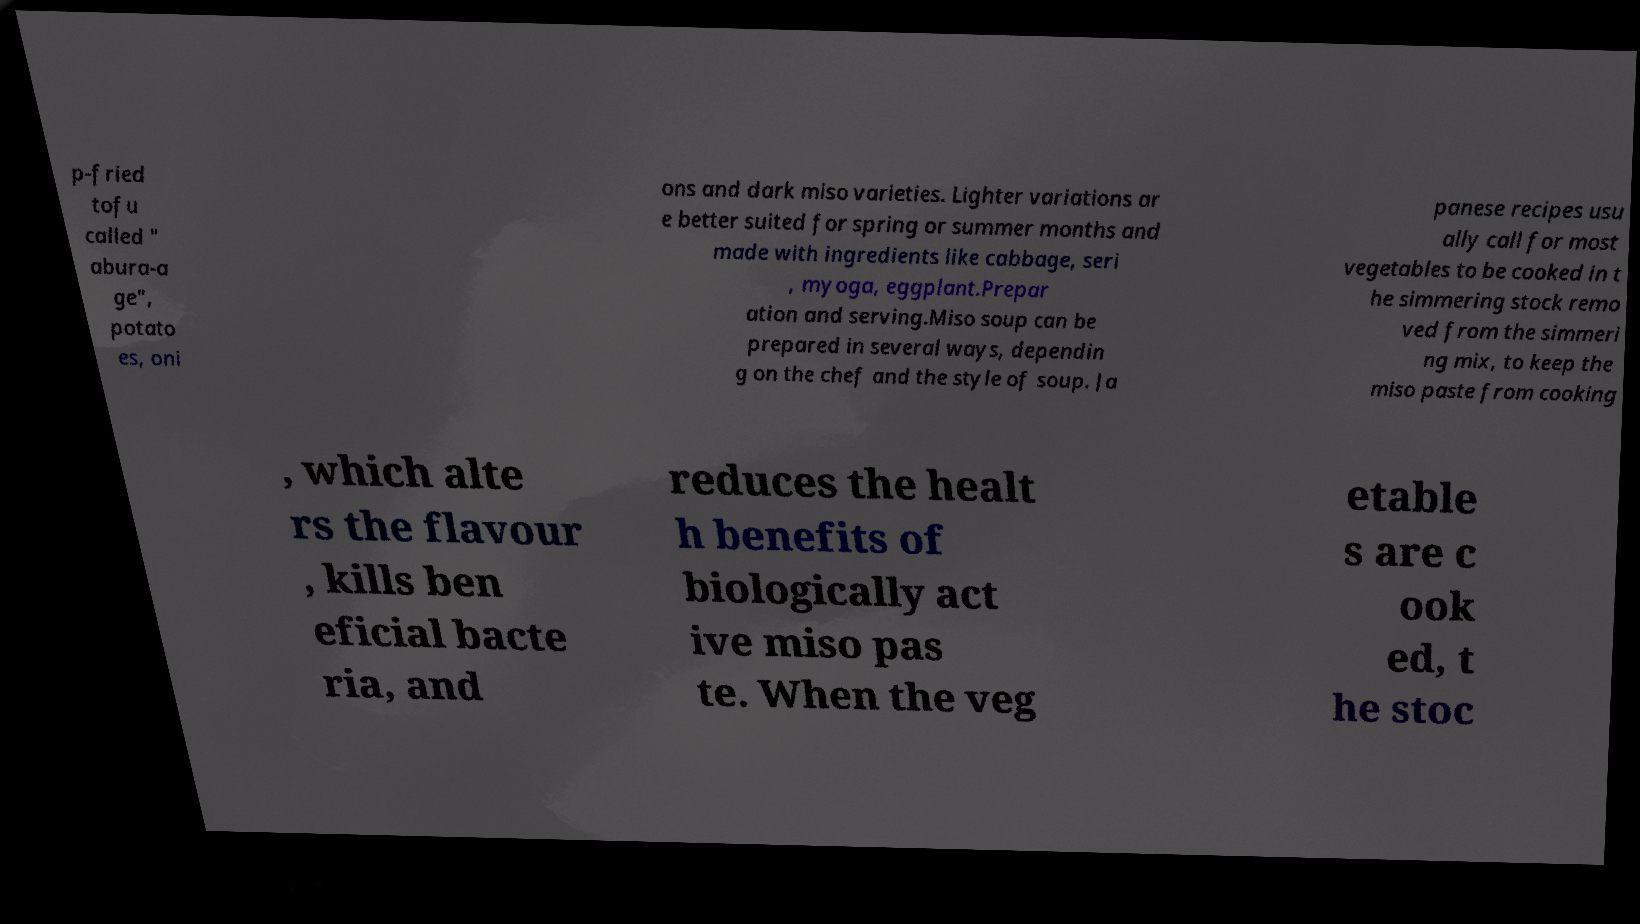Could you extract and type out the text from this image? p-fried tofu called " abura-a ge", potato es, oni ons and dark miso varieties. Lighter variations ar e better suited for spring or summer months and made with ingredients like cabbage, seri , myoga, eggplant.Prepar ation and serving.Miso soup can be prepared in several ways, dependin g on the chef and the style of soup. Ja panese recipes usu ally call for most vegetables to be cooked in t he simmering stock remo ved from the simmeri ng mix, to keep the miso paste from cooking , which alte rs the flavour , kills ben eficial bacte ria, and reduces the healt h benefits of biologically act ive miso pas te. When the veg etable s are c ook ed, t he stoc 